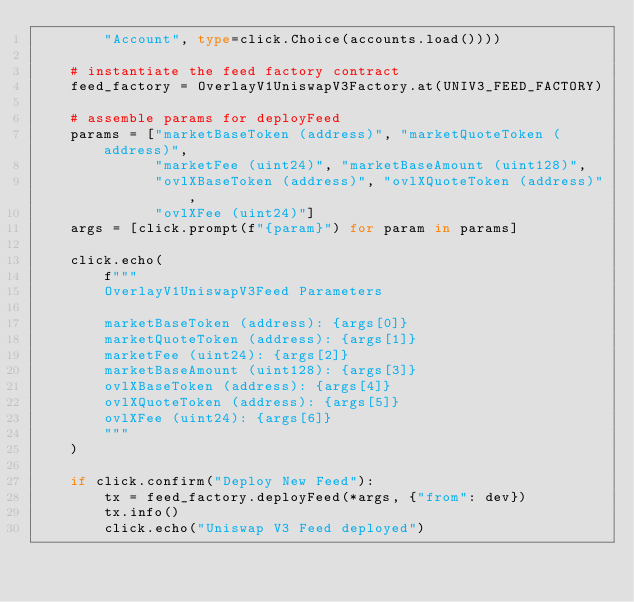<code> <loc_0><loc_0><loc_500><loc_500><_Python_>        "Account", type=click.Choice(accounts.load())))

    # instantiate the feed factory contract
    feed_factory = OverlayV1UniswapV3Factory.at(UNIV3_FEED_FACTORY)

    # assemble params for deployFeed
    params = ["marketBaseToken (address)", "marketQuoteToken (address)",
              "marketFee (uint24)", "marketBaseAmount (uint128)",
              "ovlXBaseToken (address)", "ovlXQuoteToken (address)",
              "ovlXFee (uint24)"]
    args = [click.prompt(f"{param}") for param in params]

    click.echo(
        f"""
        OverlayV1UniswapV3Feed Parameters

        marketBaseToken (address): {args[0]}
        marketQuoteToken (address): {args[1]}
        marketFee (uint24): {args[2]}
        marketBaseAmount (uint128): {args[3]}
        ovlXBaseToken (address): {args[4]}
        ovlXQuoteToken (address): {args[5]}
        ovlXFee (uint24): {args[6]}
        """
    )

    if click.confirm("Deploy New Feed"):
        tx = feed_factory.deployFeed(*args, {"from": dev})
        tx.info()
        click.echo("Uniswap V3 Feed deployed")
</code> 